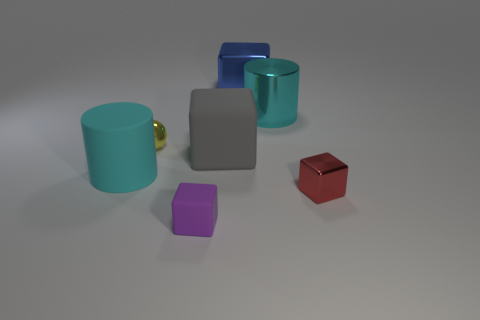There is a big matte object that is the same color as the big metal cylinder; what shape is it?
Ensure brevity in your answer.  Cylinder. The object that is in front of the big matte cylinder and to the left of the large gray matte block is made of what material?
Provide a succinct answer. Rubber. Are there fewer large gray rubber cubes in front of the small ball than things in front of the blue object?
Your answer should be very brief. Yes. What is the size of the red cube that is made of the same material as the yellow thing?
Ensure brevity in your answer.  Small. Is there any other thing that has the same color as the sphere?
Your response must be concise. No. Are the red block and the cyan cylinder that is on the right side of the tiny purple matte block made of the same material?
Keep it short and to the point. Yes. What is the material of the tiny red object that is the same shape as the purple rubber thing?
Ensure brevity in your answer.  Metal. Is the tiny block that is left of the small red cube made of the same material as the cylinder that is on the left side of the big metallic block?
Offer a terse response. Yes. There is a big matte object on the right side of the matte thing that is in front of the metal object that is in front of the small yellow metal ball; what color is it?
Ensure brevity in your answer.  Gray. How many other things are the same shape as the small purple thing?
Your answer should be compact. 3. 